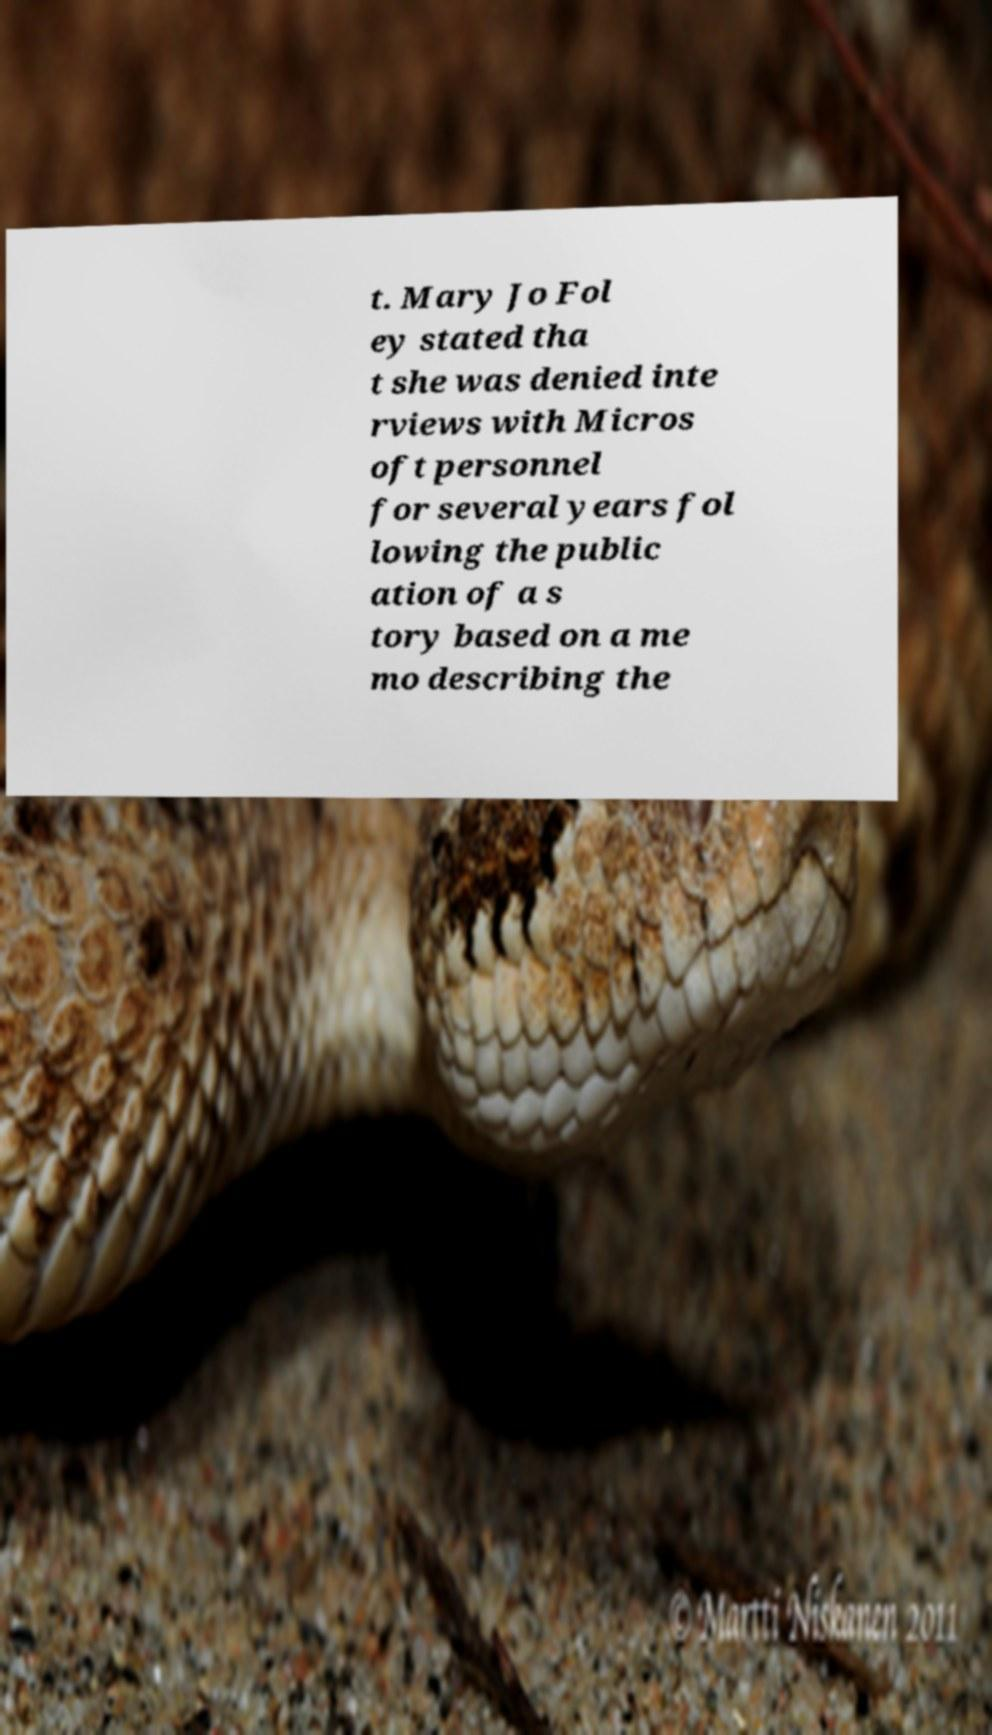Can you read and provide the text displayed in the image?This photo seems to have some interesting text. Can you extract and type it out for me? t. Mary Jo Fol ey stated tha t she was denied inte rviews with Micros oft personnel for several years fol lowing the public ation of a s tory based on a me mo describing the 